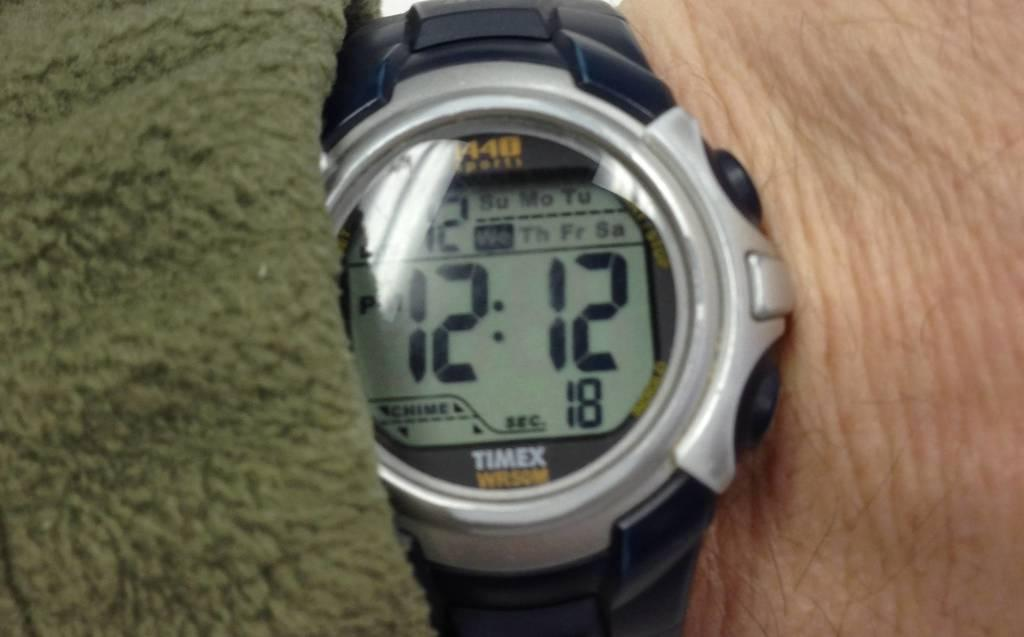<image>
Create a compact narrative representing the image presented. A digital watch that says Timex on it, and the time is 12:12 